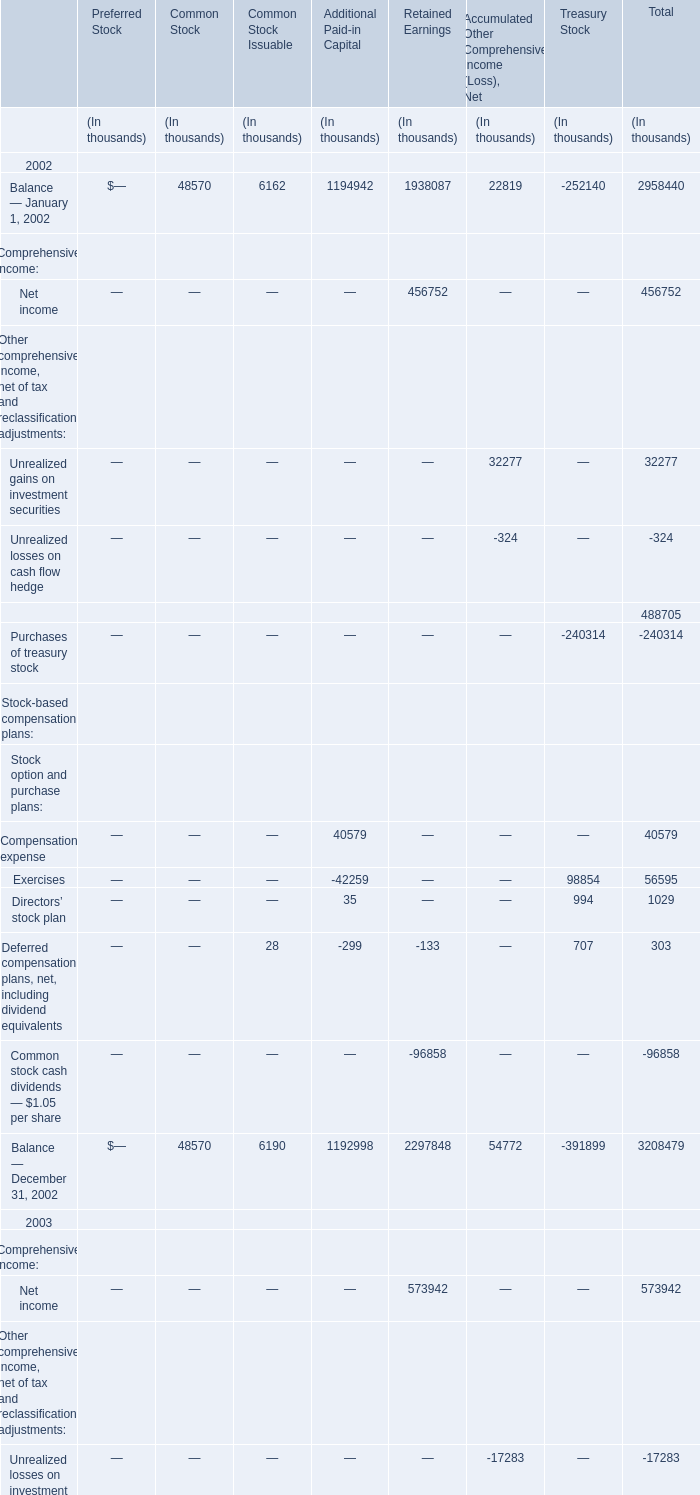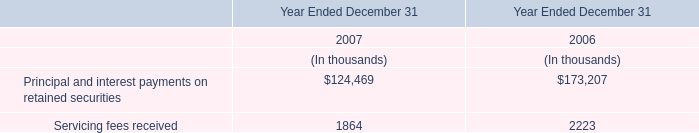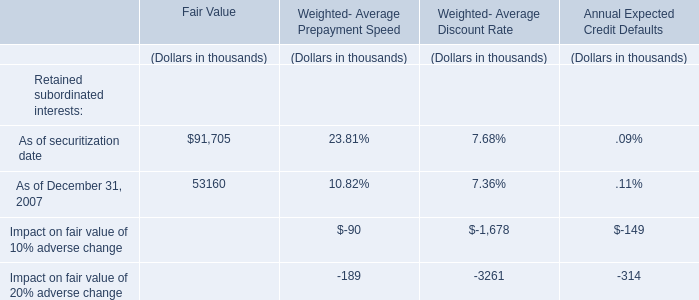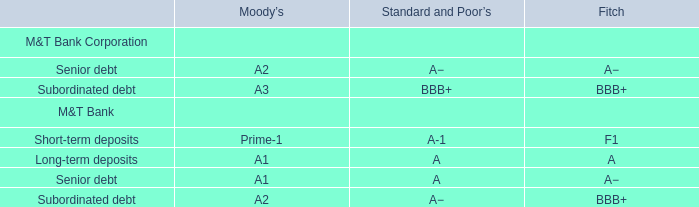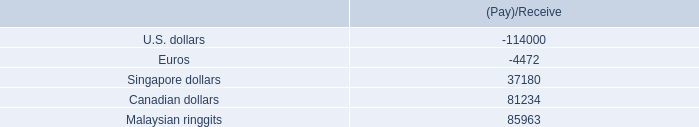what is a rough estimate of the ratio of securities given to securities received? 
Computations: ((114000 + 4472) / (85963 + (37180 + 81234)))
Answer: 0.57967. 